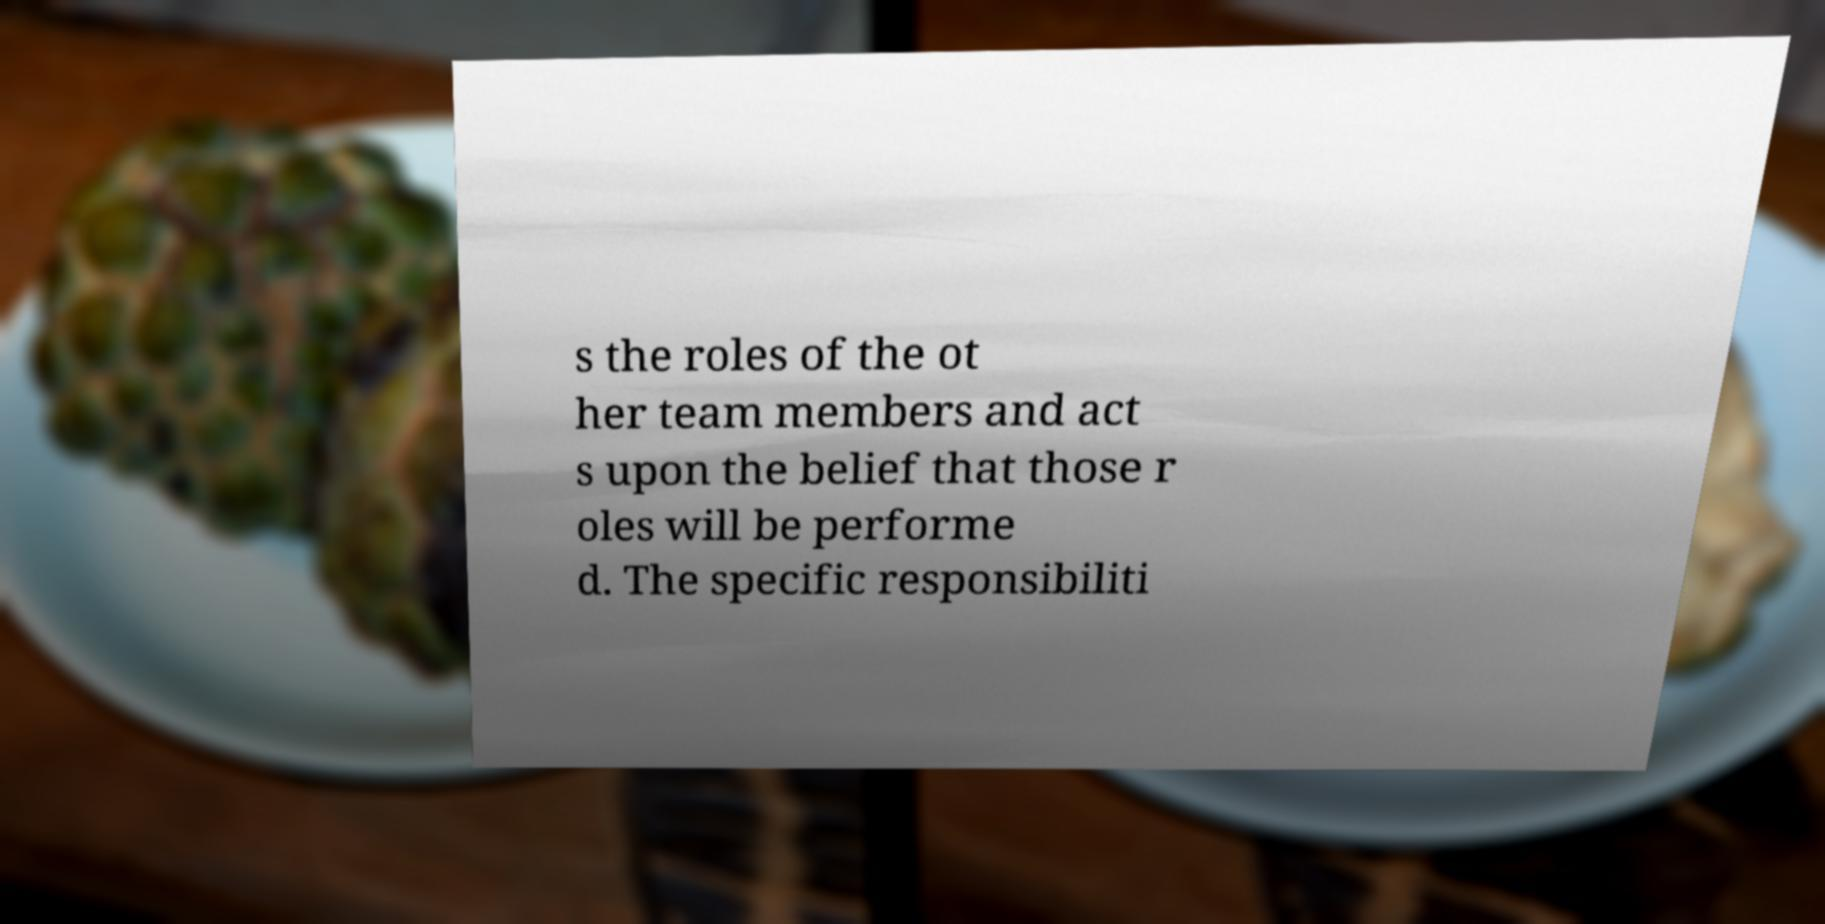Can you accurately transcribe the text from the provided image for me? s the roles of the ot her team members and act s upon the belief that those r oles will be performe d. The specific responsibiliti 